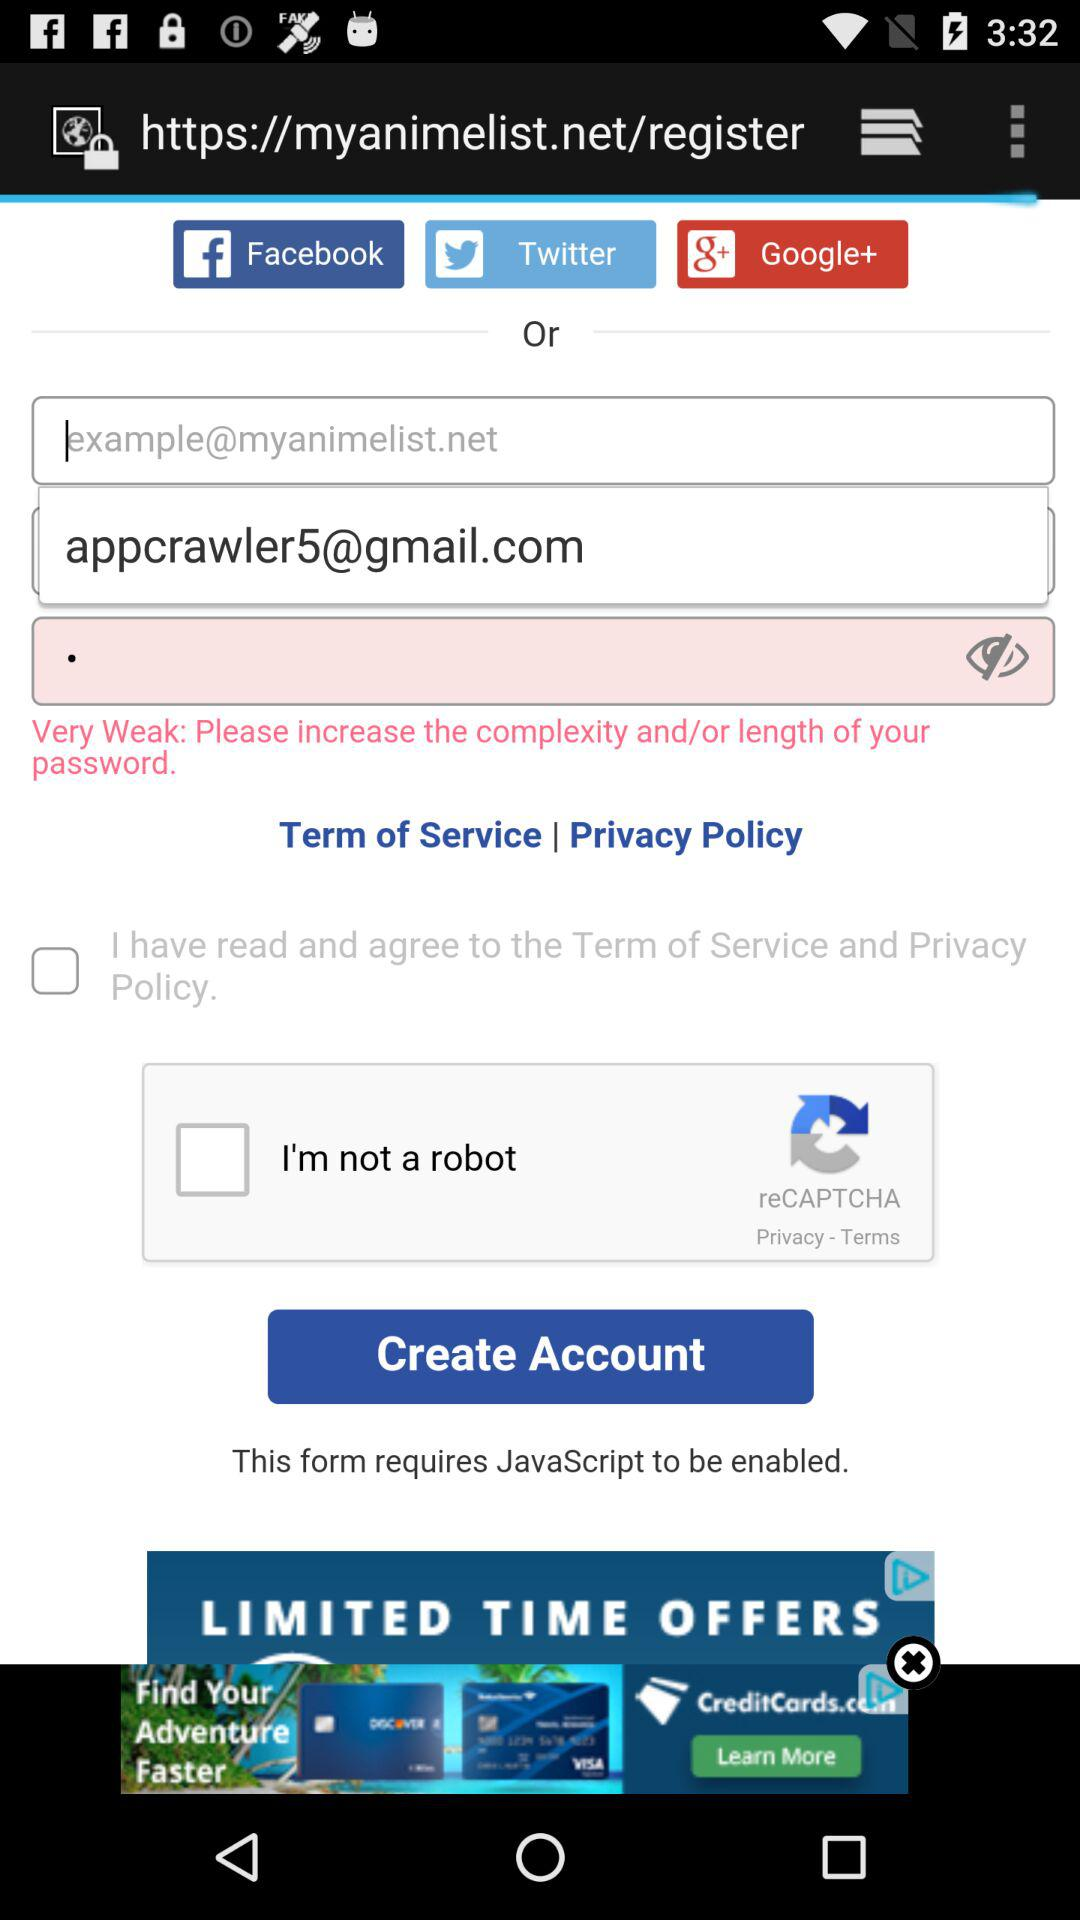What is the shown email address? The shown email address is appcrawler5@gmail.com. 